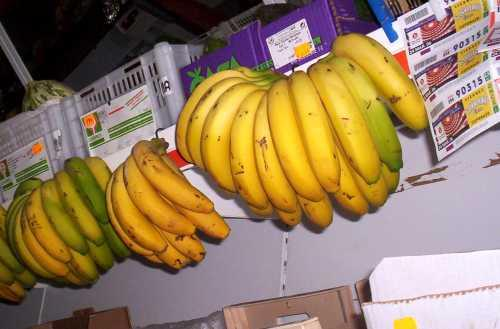Using informal language, describe the color of the wall and the numbers visible on the piece of paper. The wall's, like, totally white, dude. Oh, and the numbers on the paper are 9 and 0. Discuss the possible sentiment and emotions that could be conveyed by this image. The image may convey a sense of freshness and variety, as well as a casual, everyday shopping experience at a local store. Describe the scene in the image, focusing on the bananas and their state. There are several bunches of bananas hanging with a mix of green and yellow ones. Some of the bananas have noticeable bruises, indicating different stages of ripeness. Create a creative caption for the image, focusing on the variety of banana ripeness. "Banana Bonanza: A Dynamic Symphony of Colors in the Fruit Aisle!" Count the total number of objects related to bananas in the image. There are 19 objects related to bananas in the image. Write a detailed description of the image, focusing on the objects located on the shelves. There is a purple box, a white plastic crate, and a white cardboard box on the shelves above and below the bananas. The white crate is placed next to the purple box, while the cardboard box has a yellow sticker. Determine the overall quality of the image in terms of the objects and their details. The image is of good quality, showcasing various objects with clear details such as bruises on bananas, barcodes on paper, and numbers on stickers. Identify three objects on the shelves and specify their colors. A purple cardboard, a white plastic bin, and a white cardboard box with a yellow sticker. Analyze and describe any interactions between objects in the image. The bananas are interacting with the shelves, by hanging above and below them. The white crate is also interacting with the purple box, as they are placed next to each other on the same shelf. How many bruises can be seen on the bananas? There are bruises on one yellow banana and one green banana. Is there a black wall in the shop? The wall in the image is specified to be white. So asking about a black wall brings confusion as it is not present. Can you find a number 7 on the piece of paper? The numbers mentioned on the piece of paper are 9 and 0. Asking about a number 7 brings confusion and is misleading. Can you see the red bananas among the bunch? There are only green and yellow bananas in the image, mentioning red bananas is misleading as they do not exist in the image. Can you find a blue stripe on a shelf? The stripe on the shelf is mentioned as orange. Asking about a blue stripe creates confusion as it does not appear in the image. Is there a red label on the white plastic bin? The label on the white plastic bin is mentioned as green and white. Asking for a red label is misleading as it does not exist in the image. Is there a pink cardboard box on the shelf? The image has a purple cardboard box, not a pink one. So, asking about a pink box is incorrect and confusing. 